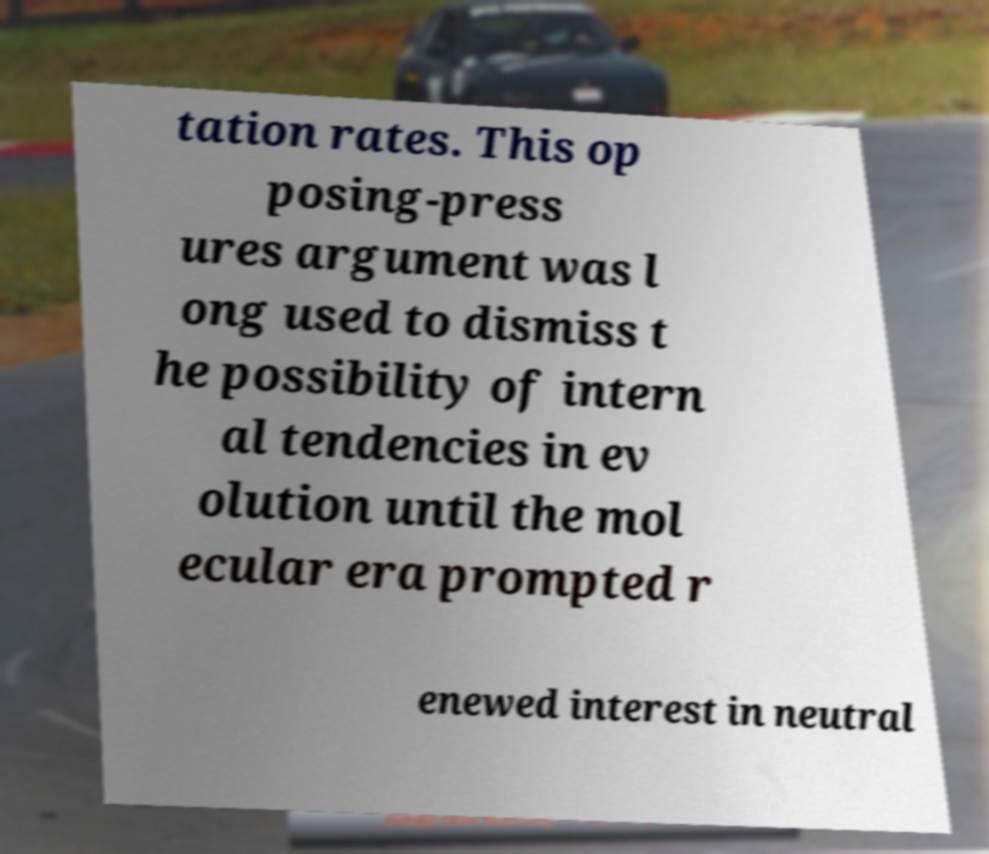What messages or text are displayed in this image? I need them in a readable, typed format. tation rates. This op posing-press ures argument was l ong used to dismiss t he possibility of intern al tendencies in ev olution until the mol ecular era prompted r enewed interest in neutral 